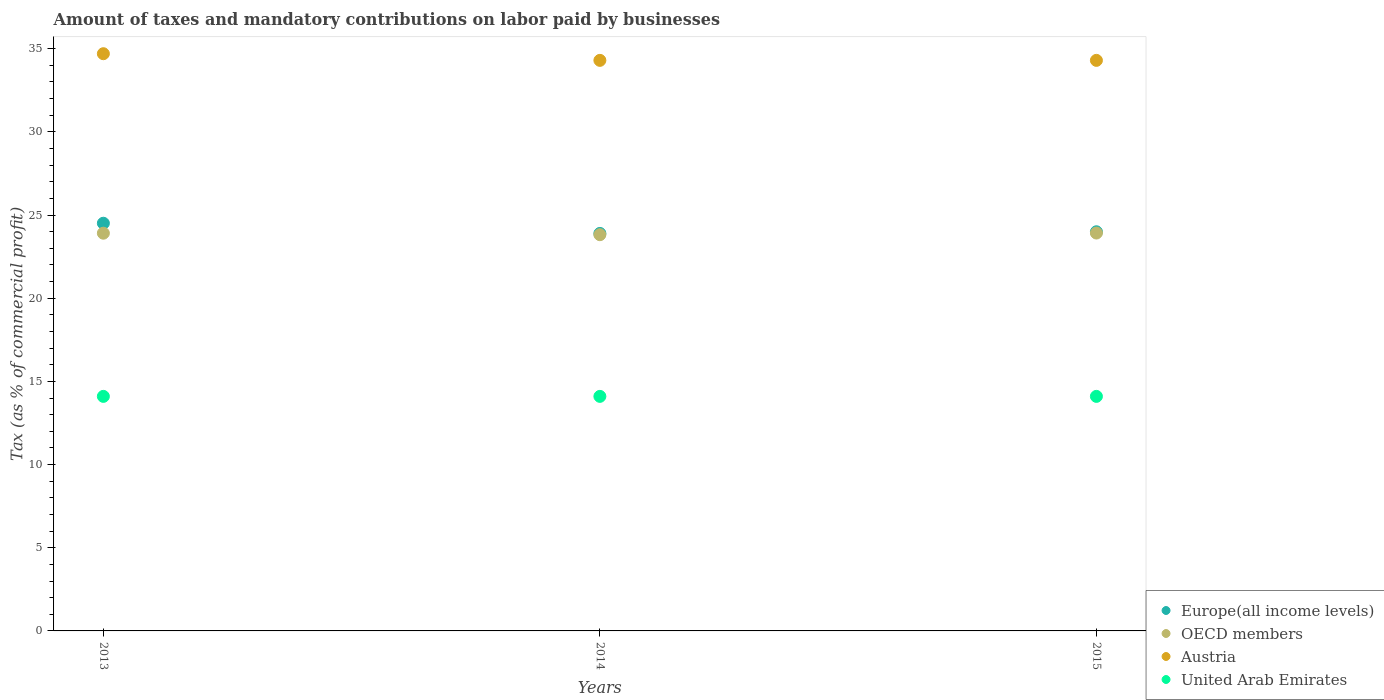How many different coloured dotlines are there?
Your answer should be compact. 4. Is the number of dotlines equal to the number of legend labels?
Your answer should be compact. Yes. What is the percentage of taxes paid by businesses in Austria in 2014?
Ensure brevity in your answer.  34.3. Across all years, what is the minimum percentage of taxes paid by businesses in United Arab Emirates?
Your answer should be very brief. 14.1. In which year was the percentage of taxes paid by businesses in Austria minimum?
Offer a terse response. 2014. What is the total percentage of taxes paid by businesses in Europe(all income levels) in the graph?
Keep it short and to the point. 72.4. What is the difference between the percentage of taxes paid by businesses in OECD members in 2014 and that in 2015?
Offer a terse response. -0.1. What is the difference between the percentage of taxes paid by businesses in OECD members in 2013 and the percentage of taxes paid by businesses in Europe(all income levels) in 2014?
Your response must be concise. 0.01. What is the average percentage of taxes paid by businesses in Europe(all income levels) per year?
Your response must be concise. 24.13. In the year 2015, what is the difference between the percentage of taxes paid by businesses in United Arab Emirates and percentage of taxes paid by businesses in OECD members?
Make the answer very short. -9.82. In how many years, is the percentage of taxes paid by businesses in United Arab Emirates greater than 2 %?
Your response must be concise. 3. What is the ratio of the percentage of taxes paid by businesses in Austria in 2013 to that in 2015?
Give a very brief answer. 1.01. Is the percentage of taxes paid by businesses in Austria in 2013 less than that in 2015?
Offer a very short reply. No. What is the difference between the highest and the second highest percentage of taxes paid by businesses in OECD members?
Provide a succinct answer. 0.01. What is the difference between the highest and the lowest percentage of taxes paid by businesses in Europe(all income levels)?
Make the answer very short. 0.61. In how many years, is the percentage of taxes paid by businesses in United Arab Emirates greater than the average percentage of taxes paid by businesses in United Arab Emirates taken over all years?
Provide a succinct answer. 0. Is it the case that in every year, the sum of the percentage of taxes paid by businesses in OECD members and percentage of taxes paid by businesses in Austria  is greater than the percentage of taxes paid by businesses in United Arab Emirates?
Your response must be concise. Yes. Does the percentage of taxes paid by businesses in OECD members monotonically increase over the years?
Offer a very short reply. No. How many dotlines are there?
Your response must be concise. 4. How many years are there in the graph?
Your answer should be very brief. 3. Are the values on the major ticks of Y-axis written in scientific E-notation?
Provide a succinct answer. No. Does the graph contain any zero values?
Provide a short and direct response. No. How many legend labels are there?
Your response must be concise. 4. How are the legend labels stacked?
Make the answer very short. Vertical. What is the title of the graph?
Provide a short and direct response. Amount of taxes and mandatory contributions on labor paid by businesses. What is the label or title of the Y-axis?
Keep it short and to the point. Tax (as % of commercial profit). What is the Tax (as % of commercial profit) of Europe(all income levels) in 2013?
Offer a very short reply. 24.51. What is the Tax (as % of commercial profit) in OECD members in 2013?
Provide a short and direct response. 23.91. What is the Tax (as % of commercial profit) of Austria in 2013?
Your response must be concise. 34.7. What is the Tax (as % of commercial profit) of United Arab Emirates in 2013?
Keep it short and to the point. 14.1. What is the Tax (as % of commercial profit) of Europe(all income levels) in 2014?
Give a very brief answer. 23.9. What is the Tax (as % of commercial profit) of OECD members in 2014?
Your answer should be very brief. 23.82. What is the Tax (as % of commercial profit) in Austria in 2014?
Provide a succinct answer. 34.3. What is the Tax (as % of commercial profit) of United Arab Emirates in 2014?
Make the answer very short. 14.1. What is the Tax (as % of commercial profit) in Europe(all income levels) in 2015?
Keep it short and to the point. 24. What is the Tax (as % of commercial profit) in OECD members in 2015?
Your answer should be very brief. 23.92. What is the Tax (as % of commercial profit) of Austria in 2015?
Offer a very short reply. 34.3. Across all years, what is the maximum Tax (as % of commercial profit) of Europe(all income levels)?
Your answer should be very brief. 24.51. Across all years, what is the maximum Tax (as % of commercial profit) of OECD members?
Provide a short and direct response. 23.92. Across all years, what is the maximum Tax (as % of commercial profit) of Austria?
Offer a very short reply. 34.7. Across all years, what is the minimum Tax (as % of commercial profit) of Europe(all income levels)?
Offer a very short reply. 23.9. Across all years, what is the minimum Tax (as % of commercial profit) of OECD members?
Provide a short and direct response. 23.82. Across all years, what is the minimum Tax (as % of commercial profit) in Austria?
Keep it short and to the point. 34.3. Across all years, what is the minimum Tax (as % of commercial profit) of United Arab Emirates?
Offer a very short reply. 14.1. What is the total Tax (as % of commercial profit) in Europe(all income levels) in the graph?
Offer a very short reply. 72.4. What is the total Tax (as % of commercial profit) in OECD members in the graph?
Your response must be concise. 71.65. What is the total Tax (as % of commercial profit) in Austria in the graph?
Your answer should be very brief. 103.3. What is the total Tax (as % of commercial profit) in United Arab Emirates in the graph?
Provide a short and direct response. 42.3. What is the difference between the Tax (as % of commercial profit) in Europe(all income levels) in 2013 and that in 2014?
Ensure brevity in your answer.  0.61. What is the difference between the Tax (as % of commercial profit) of OECD members in 2013 and that in 2014?
Keep it short and to the point. 0.09. What is the difference between the Tax (as % of commercial profit) of Europe(all income levels) in 2013 and that in 2015?
Ensure brevity in your answer.  0.51. What is the difference between the Tax (as % of commercial profit) of OECD members in 2013 and that in 2015?
Make the answer very short. -0.01. What is the difference between the Tax (as % of commercial profit) in Austria in 2013 and that in 2015?
Keep it short and to the point. 0.4. What is the difference between the Tax (as % of commercial profit) in OECD members in 2014 and that in 2015?
Ensure brevity in your answer.  -0.1. What is the difference between the Tax (as % of commercial profit) of Austria in 2014 and that in 2015?
Your answer should be compact. 0. What is the difference between the Tax (as % of commercial profit) in Europe(all income levels) in 2013 and the Tax (as % of commercial profit) in OECD members in 2014?
Your answer should be compact. 0.69. What is the difference between the Tax (as % of commercial profit) in Europe(all income levels) in 2013 and the Tax (as % of commercial profit) in Austria in 2014?
Keep it short and to the point. -9.79. What is the difference between the Tax (as % of commercial profit) in Europe(all income levels) in 2013 and the Tax (as % of commercial profit) in United Arab Emirates in 2014?
Your answer should be very brief. 10.41. What is the difference between the Tax (as % of commercial profit) in OECD members in 2013 and the Tax (as % of commercial profit) in Austria in 2014?
Make the answer very short. -10.39. What is the difference between the Tax (as % of commercial profit) of OECD members in 2013 and the Tax (as % of commercial profit) of United Arab Emirates in 2014?
Your answer should be very brief. 9.81. What is the difference between the Tax (as % of commercial profit) of Austria in 2013 and the Tax (as % of commercial profit) of United Arab Emirates in 2014?
Ensure brevity in your answer.  20.6. What is the difference between the Tax (as % of commercial profit) of Europe(all income levels) in 2013 and the Tax (as % of commercial profit) of OECD members in 2015?
Offer a very short reply. 0.59. What is the difference between the Tax (as % of commercial profit) in Europe(all income levels) in 2013 and the Tax (as % of commercial profit) in Austria in 2015?
Provide a short and direct response. -9.79. What is the difference between the Tax (as % of commercial profit) in Europe(all income levels) in 2013 and the Tax (as % of commercial profit) in United Arab Emirates in 2015?
Give a very brief answer. 10.41. What is the difference between the Tax (as % of commercial profit) in OECD members in 2013 and the Tax (as % of commercial profit) in Austria in 2015?
Offer a very short reply. -10.39. What is the difference between the Tax (as % of commercial profit) in OECD members in 2013 and the Tax (as % of commercial profit) in United Arab Emirates in 2015?
Offer a terse response. 9.81. What is the difference between the Tax (as % of commercial profit) in Austria in 2013 and the Tax (as % of commercial profit) in United Arab Emirates in 2015?
Offer a very short reply. 20.6. What is the difference between the Tax (as % of commercial profit) of Europe(all income levels) in 2014 and the Tax (as % of commercial profit) of OECD members in 2015?
Give a very brief answer. -0.02. What is the difference between the Tax (as % of commercial profit) of Europe(all income levels) in 2014 and the Tax (as % of commercial profit) of Austria in 2015?
Your answer should be very brief. -10.4. What is the difference between the Tax (as % of commercial profit) of Europe(all income levels) in 2014 and the Tax (as % of commercial profit) of United Arab Emirates in 2015?
Offer a very short reply. 9.8. What is the difference between the Tax (as % of commercial profit) of OECD members in 2014 and the Tax (as % of commercial profit) of Austria in 2015?
Ensure brevity in your answer.  -10.48. What is the difference between the Tax (as % of commercial profit) of OECD members in 2014 and the Tax (as % of commercial profit) of United Arab Emirates in 2015?
Provide a succinct answer. 9.72. What is the difference between the Tax (as % of commercial profit) of Austria in 2014 and the Tax (as % of commercial profit) of United Arab Emirates in 2015?
Your answer should be very brief. 20.2. What is the average Tax (as % of commercial profit) in Europe(all income levels) per year?
Make the answer very short. 24.13. What is the average Tax (as % of commercial profit) in OECD members per year?
Your answer should be compact. 23.88. What is the average Tax (as % of commercial profit) of Austria per year?
Your answer should be very brief. 34.43. What is the average Tax (as % of commercial profit) of United Arab Emirates per year?
Make the answer very short. 14.1. In the year 2013, what is the difference between the Tax (as % of commercial profit) in Europe(all income levels) and Tax (as % of commercial profit) in OECD members?
Offer a very short reply. 0.6. In the year 2013, what is the difference between the Tax (as % of commercial profit) of Europe(all income levels) and Tax (as % of commercial profit) of Austria?
Give a very brief answer. -10.19. In the year 2013, what is the difference between the Tax (as % of commercial profit) in Europe(all income levels) and Tax (as % of commercial profit) in United Arab Emirates?
Offer a very short reply. 10.41. In the year 2013, what is the difference between the Tax (as % of commercial profit) in OECD members and Tax (as % of commercial profit) in Austria?
Offer a terse response. -10.79. In the year 2013, what is the difference between the Tax (as % of commercial profit) of OECD members and Tax (as % of commercial profit) of United Arab Emirates?
Give a very brief answer. 9.81. In the year 2013, what is the difference between the Tax (as % of commercial profit) of Austria and Tax (as % of commercial profit) of United Arab Emirates?
Give a very brief answer. 20.6. In the year 2014, what is the difference between the Tax (as % of commercial profit) in Europe(all income levels) and Tax (as % of commercial profit) in OECD members?
Provide a succinct answer. 0.08. In the year 2014, what is the difference between the Tax (as % of commercial profit) of Europe(all income levels) and Tax (as % of commercial profit) of Austria?
Make the answer very short. -10.4. In the year 2014, what is the difference between the Tax (as % of commercial profit) of Europe(all income levels) and Tax (as % of commercial profit) of United Arab Emirates?
Offer a very short reply. 9.8. In the year 2014, what is the difference between the Tax (as % of commercial profit) of OECD members and Tax (as % of commercial profit) of Austria?
Keep it short and to the point. -10.48. In the year 2014, what is the difference between the Tax (as % of commercial profit) in OECD members and Tax (as % of commercial profit) in United Arab Emirates?
Your answer should be very brief. 9.72. In the year 2014, what is the difference between the Tax (as % of commercial profit) in Austria and Tax (as % of commercial profit) in United Arab Emirates?
Your response must be concise. 20.2. In the year 2015, what is the difference between the Tax (as % of commercial profit) in Europe(all income levels) and Tax (as % of commercial profit) in OECD members?
Keep it short and to the point. 0.08. In the year 2015, what is the difference between the Tax (as % of commercial profit) in Europe(all income levels) and Tax (as % of commercial profit) in Austria?
Your answer should be compact. -10.3. In the year 2015, what is the difference between the Tax (as % of commercial profit) of Europe(all income levels) and Tax (as % of commercial profit) of United Arab Emirates?
Keep it short and to the point. 9.9. In the year 2015, what is the difference between the Tax (as % of commercial profit) in OECD members and Tax (as % of commercial profit) in Austria?
Provide a succinct answer. -10.38. In the year 2015, what is the difference between the Tax (as % of commercial profit) in OECD members and Tax (as % of commercial profit) in United Arab Emirates?
Keep it short and to the point. 9.82. In the year 2015, what is the difference between the Tax (as % of commercial profit) in Austria and Tax (as % of commercial profit) in United Arab Emirates?
Your response must be concise. 20.2. What is the ratio of the Tax (as % of commercial profit) of Europe(all income levels) in 2013 to that in 2014?
Offer a very short reply. 1.03. What is the ratio of the Tax (as % of commercial profit) in OECD members in 2013 to that in 2014?
Keep it short and to the point. 1. What is the ratio of the Tax (as % of commercial profit) of Austria in 2013 to that in 2014?
Provide a short and direct response. 1.01. What is the ratio of the Tax (as % of commercial profit) in United Arab Emirates in 2013 to that in 2014?
Make the answer very short. 1. What is the ratio of the Tax (as % of commercial profit) in Europe(all income levels) in 2013 to that in 2015?
Offer a terse response. 1.02. What is the ratio of the Tax (as % of commercial profit) in OECD members in 2013 to that in 2015?
Your answer should be very brief. 1. What is the ratio of the Tax (as % of commercial profit) in Austria in 2013 to that in 2015?
Your answer should be very brief. 1.01. What is the ratio of the Tax (as % of commercial profit) of OECD members in 2014 to that in 2015?
Offer a very short reply. 1. What is the ratio of the Tax (as % of commercial profit) in Austria in 2014 to that in 2015?
Give a very brief answer. 1. What is the difference between the highest and the second highest Tax (as % of commercial profit) of Europe(all income levels)?
Keep it short and to the point. 0.51. What is the difference between the highest and the second highest Tax (as % of commercial profit) in OECD members?
Offer a very short reply. 0.01. What is the difference between the highest and the second highest Tax (as % of commercial profit) of Austria?
Your answer should be compact. 0.4. What is the difference between the highest and the lowest Tax (as % of commercial profit) in Europe(all income levels)?
Provide a succinct answer. 0.61. What is the difference between the highest and the lowest Tax (as % of commercial profit) of United Arab Emirates?
Offer a very short reply. 0. 